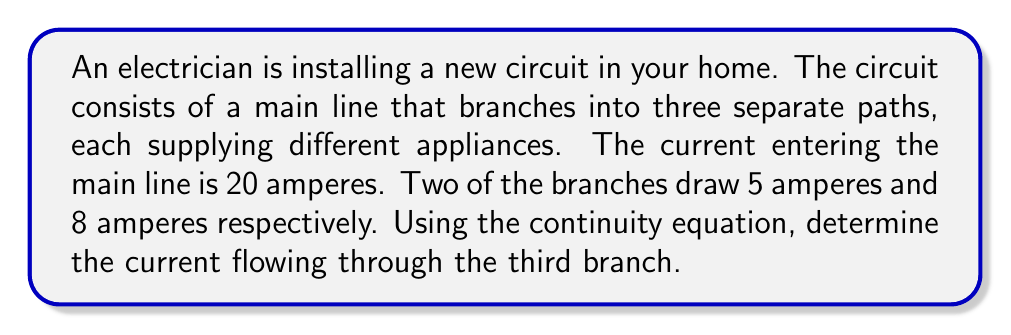Provide a solution to this math problem. To solve this problem, we'll use the continuity equation, which is a form of Kirchhoff's current law applied to electrical circuits. The continuity equation states that the sum of currents entering a junction must equal the sum of currents leaving the junction.

Let's define our variables:
$I_{\text{main}}$ = current in the main line
$I_1$, $I_2$, $I_3$ = currents in the three branches

We know:
$I_{\text{main}} = 20$ A
$I_1 = 5$ A
$I_2 = 8$ A

According to the continuity equation:

$$I_{\text{main}} = I_1 + I_2 + I_3$$

Substituting the known values:

$$20 = 5 + 8 + I_3$$

Simplifying:

$$20 = 13 + I_3$$

Solving for $I_3$:

$$I_3 = 20 - 13 = 7$$

Therefore, the current flowing through the third branch is 7 amperes.
Answer: $I_3 = 7$ A 